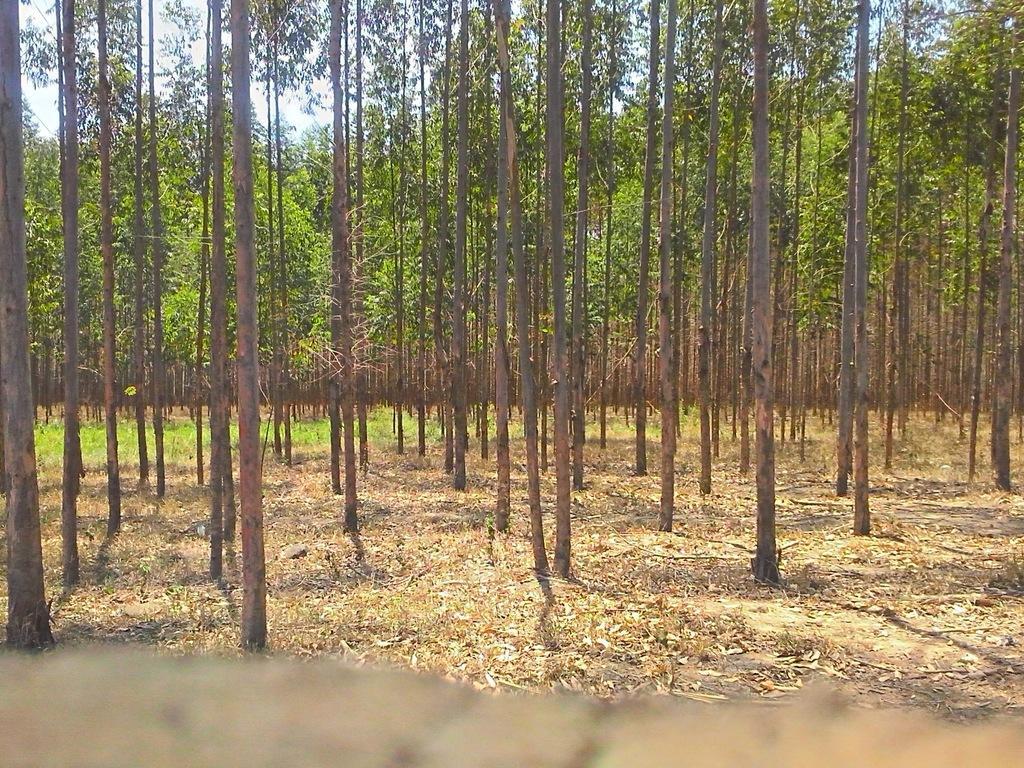Describe this image in one or two sentences. In this image there are many trees. In the foreground there are dried leaves on the ground. In the background there's grass on the ground. At the top there is the sky. 